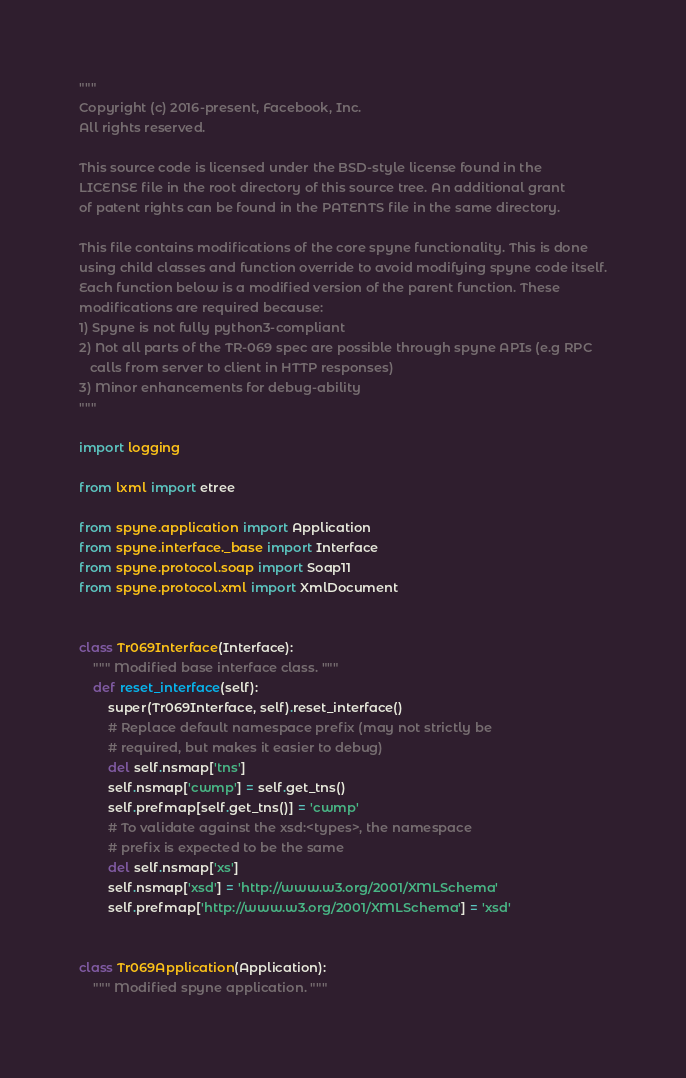<code> <loc_0><loc_0><loc_500><loc_500><_Python_>"""
Copyright (c) 2016-present, Facebook, Inc.
All rights reserved.

This source code is licensed under the BSD-style license found in the
LICENSE file in the root directory of this source tree. An additional grant
of patent rights can be found in the PATENTS file in the same directory.

This file contains modifications of the core spyne functionality. This is done
using child classes and function override to avoid modifying spyne code itself.
Each function below is a modified version of the parent function. These
modifications are required because:
1) Spyne is not fully python3-compliant
2) Not all parts of the TR-069 spec are possible through spyne APIs (e.g RPC
   calls from server to client in HTTP responses)
3) Minor enhancements for debug-ability
"""

import logging

from lxml import etree

from spyne.application import Application
from spyne.interface._base import Interface
from spyne.protocol.soap import Soap11
from spyne.protocol.xml import XmlDocument


class Tr069Interface(Interface):
    """ Modified base interface class. """
    def reset_interface(self):
        super(Tr069Interface, self).reset_interface()
        # Replace default namespace prefix (may not strictly be
        # required, but makes it easier to debug)
        del self.nsmap['tns']
        self.nsmap['cwmp'] = self.get_tns()
        self.prefmap[self.get_tns()] = 'cwmp'
        # To validate against the xsd:<types>, the namespace
        # prefix is expected to be the same
        del self.nsmap['xs']
        self.nsmap['xsd'] = 'http://www.w3.org/2001/XMLSchema'
        self.prefmap['http://www.w3.org/2001/XMLSchema'] = 'xsd'


class Tr069Application(Application):
    """ Modified spyne application. """</code> 